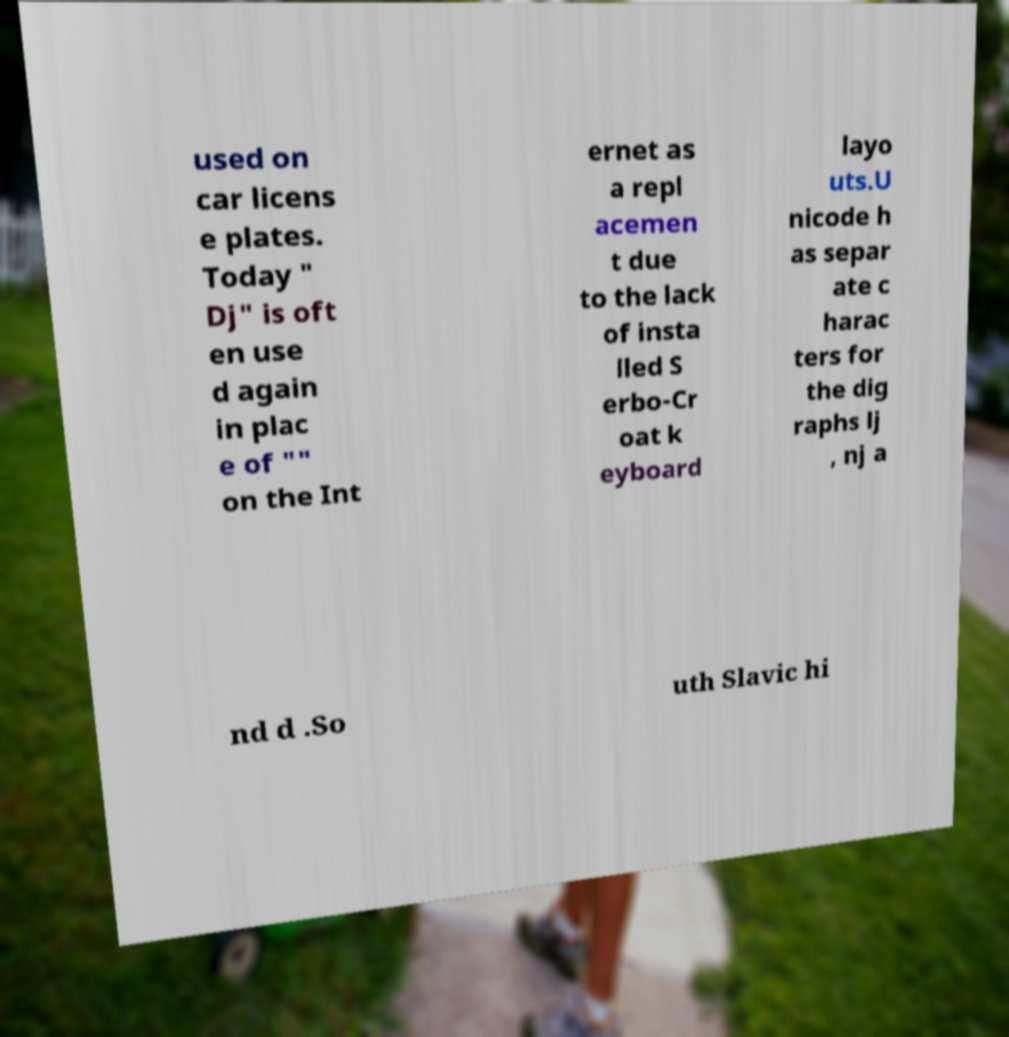Please read and relay the text visible in this image. What does it say? used on car licens e plates. Today " Dj" is oft en use d again in plac e of "" on the Int ernet as a repl acemen t due to the lack of insta lled S erbo-Cr oat k eyboard layo uts.U nicode h as separ ate c harac ters for the dig raphs lj , nj a nd d .So uth Slavic hi 